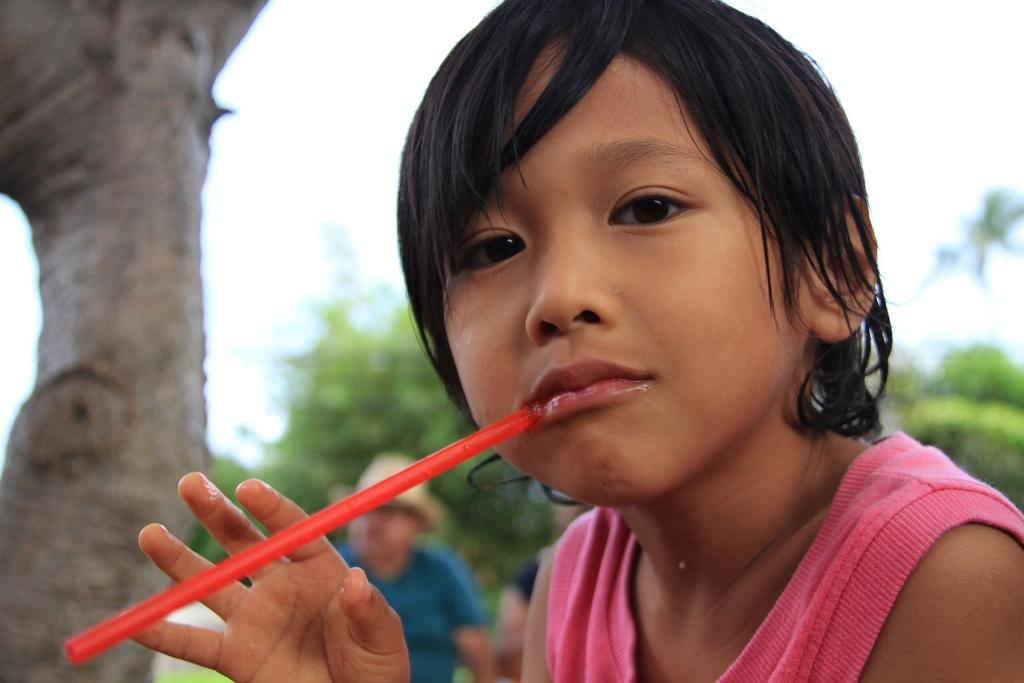Who is the main subject in the image? There is a girl in the image. What is the girl doing in the image? The girl is holding an object in her mouth. What type of natural environment is visible in the image? There are trees in the image. What part of the sky can be seen in the image? The sky is visible in the image. What type of achievement is the girl celebrating in the image? There is no indication in the image that the girl is celebrating any achievement. 